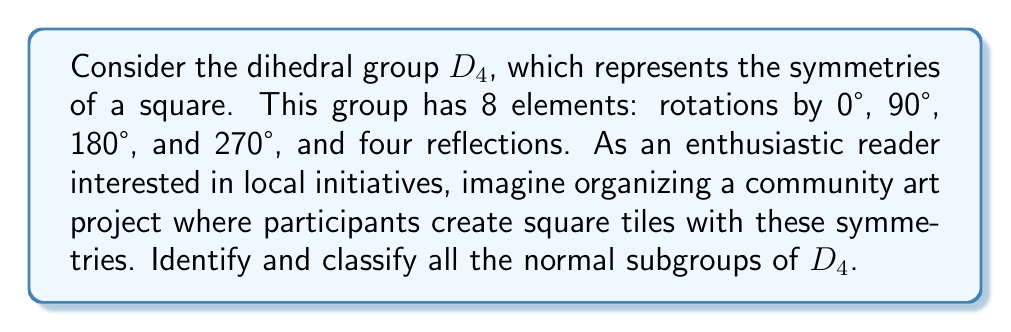Solve this math problem. To identify and classify the normal subgroups of $D_4$, we'll follow these steps:

1) First, recall that a subgroup $H$ of a group $G$ is normal if $gHg^{-1} = H$ for all $g \in G$.

2) Let's list all the elements of $D_4$:
   - $e$: identity
   - $r$: 90° rotation clockwise
   - $r^2$: 180° rotation
   - $r^3$: 270° rotation clockwise (or 90° counterclockwise)
   - $s$: reflection about a diagonal
   - $sr$: reflection about a vertical line
   - $sr^2$: reflection about the other diagonal
   - $sr^3$: reflection about a horizontal line

3) Now, let's identify all subgroups of $D_4$:
   - $\{e\}$: trivial subgroup
   - $\{e, r^2\}$: order 2 subgroup
   - $\{e, s\}$, $\{e, sr\}$, $\{e, sr^2\}$, $\{e, sr^3\}$: order 2 subgroups
   - $\{e, r, r^2, r^3\}$: cyclic subgroup of order 4
   - $\{e, r^2, s, sr^2\}$, $\{e, r^2, sr, sr^3\}$: order 4 subgroups
   - $D_4$ itself

4) To check which of these are normal, we need to verify the condition $gHg^{-1} = H$ for all $g \in D_4$:

   - $\{e\}$ is always normal in any group.
   - $\{e, r^2\}$ is normal because $r^2$ commutes with all elements of $D_4$.
   - $\{e, r, r^2, r^3\}$ is normal because it's the subgroup of rotations, which is preserved under conjugation by any element.
   - $D_4$ is normal in itself.
   - The other order 2 and order 4 subgroups are not normal, as they're not preserved under conjugation by all elements of $D_4$.

5) Classification of normal subgroups:
   - Order 1: $\{e\}$
   - Order 2: $\{e, r^2\}$
   - Order 4: $\{e, r, r^2, r^3\}$
   - Order 8: $D_4$
Answer: The normal subgroups of $D_4$ are:
1) $\{e\}$ (trivial subgroup)
2) $\{e, r^2\}$ (order 2)
3) $\{e, r, r^2, r^3\}$ (cyclic subgroup of order 4)
4) $D_4$ (the entire group) 